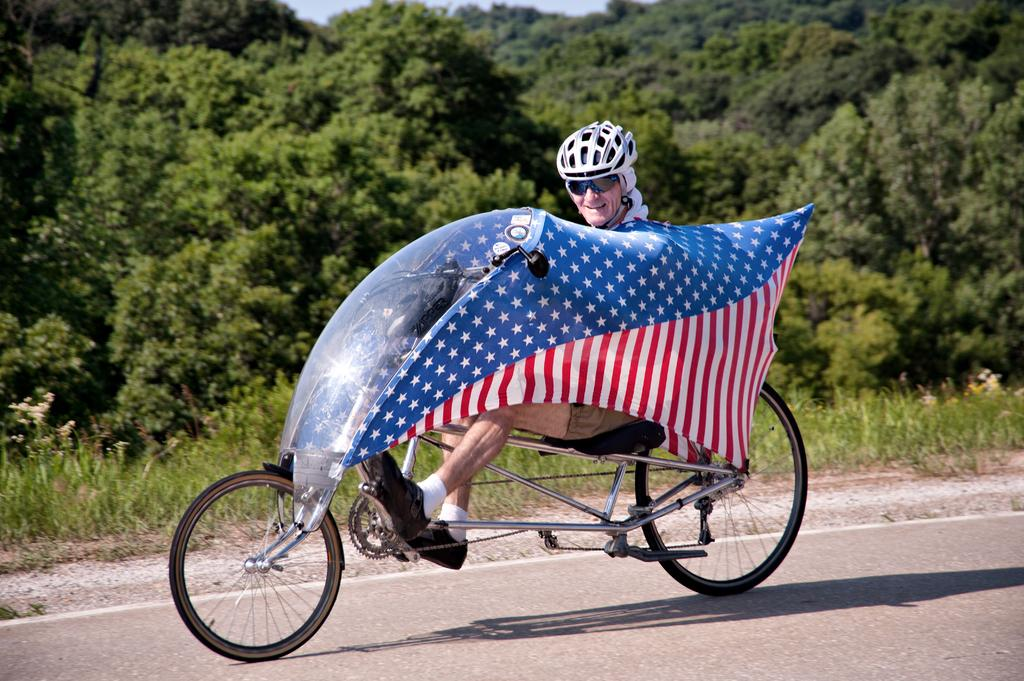What is the man in the image doing? The man is riding a bicycle in the image. Where is the bicycle located? The bicycle is on the road in the image. What can be seen in the background of the image? There is sky, trees, and grass visible in the background of the image. How many plants are being carried by the man on the bicycle? There are no plants visible in the image, and the man is not carrying any. Are the man's brothers also riding bicycles in the image? There is no mention of brothers in the image, and only one man is visible riding a bicycle. 